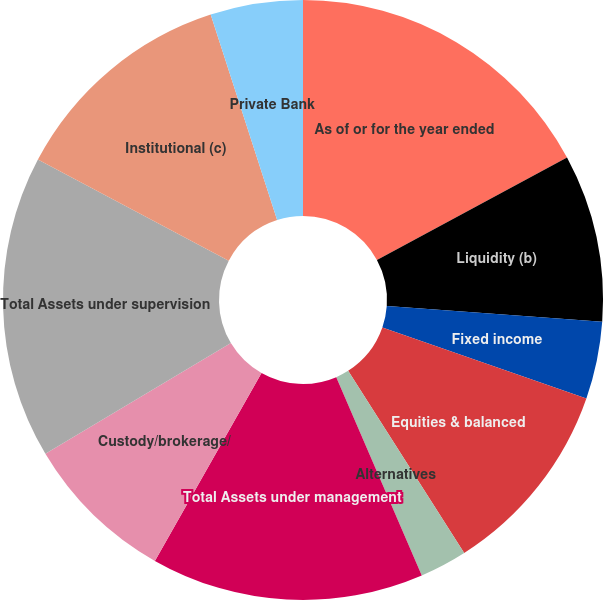Convert chart. <chart><loc_0><loc_0><loc_500><loc_500><pie_chart><fcel>As of or for the year ended<fcel>Liquidity (b)<fcel>Fixed income<fcel>Equities & balanced<fcel>Alternatives<fcel>Total Assets under management<fcel>Custody/brokerage/<fcel>Total Assets under supervision<fcel>Institutional (c)<fcel>Private Bank<nl><fcel>17.13%<fcel>9.03%<fcel>4.17%<fcel>10.65%<fcel>2.55%<fcel>14.7%<fcel>8.22%<fcel>16.32%<fcel>12.27%<fcel>4.98%<nl></chart> 